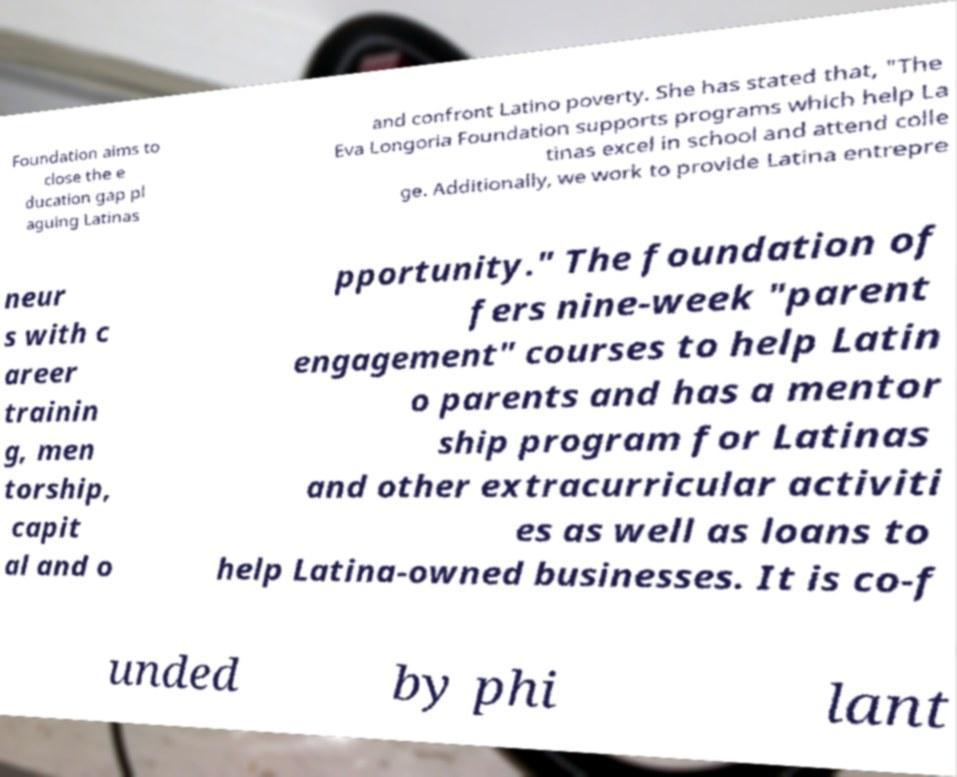What messages or text are displayed in this image? I need them in a readable, typed format. Foundation aims to close the e ducation gap pl aguing Latinas and confront Latino poverty. She has stated that, "The Eva Longoria Foundation supports programs which help La tinas excel in school and attend colle ge. Additionally, we work to provide Latina entrepre neur s with c areer trainin g, men torship, capit al and o pportunity." The foundation of fers nine-week "parent engagement" courses to help Latin o parents and has a mentor ship program for Latinas and other extracurricular activiti es as well as loans to help Latina-owned businesses. It is co-f unded by phi lant 